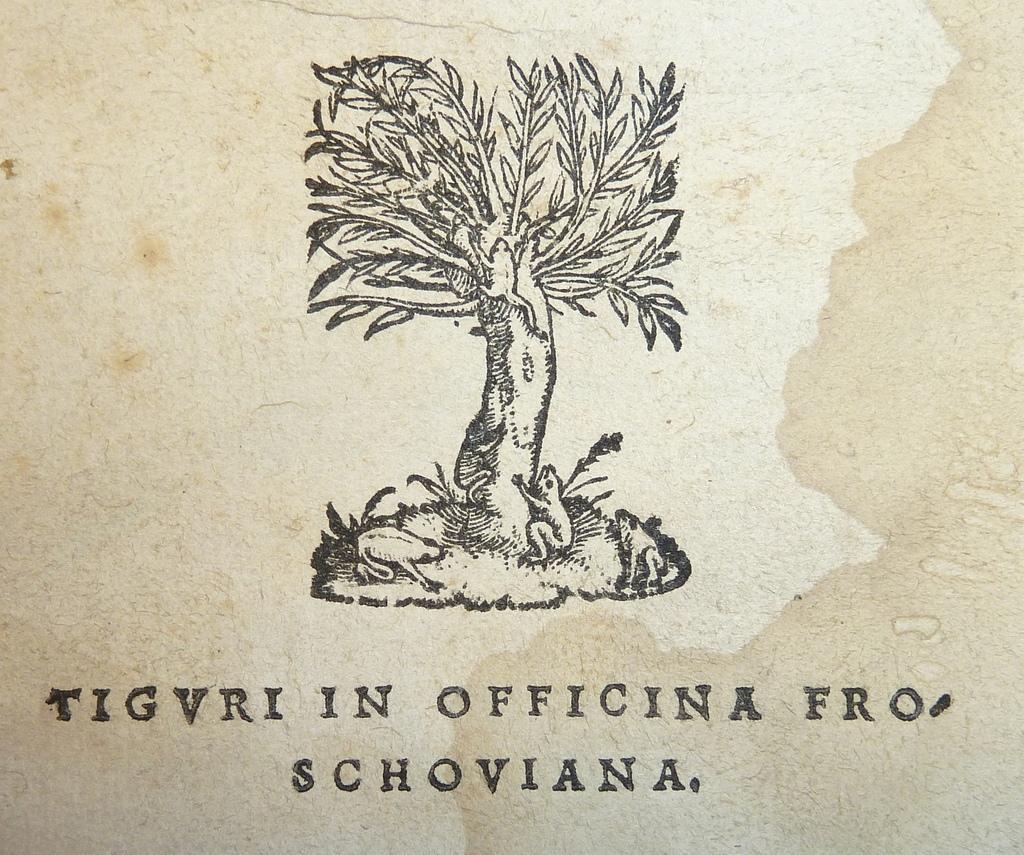Please provide a concise description of this image. In this image there is a tree, there are frogs, there are plants, there is text, the background of the image is white in color. 